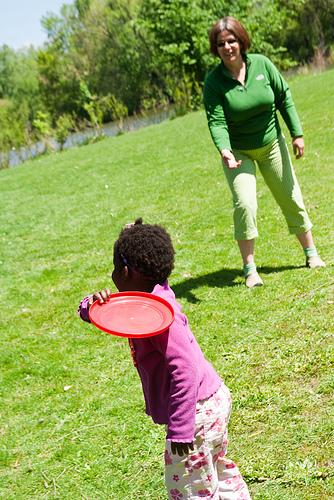Count and describe the patches of green grass depicted in the image. There are 17 patches of green grass, varying in size and position throughout the image. Describe the scene where the people are playing frisbee. The scene takes place in a green grassy field with patches of grass scattered around. The small child is holding the frisbee, preparing to throw it while the woman is nearby, possibly observing or participating in the activity. Describe the sentiment or emotions conveyed in the image. The image portrays a positive and playful atmosphere with the small child and woman enjoying outdoor activities on a sunny day. What kind of clothing accessory does the small child have on her head? The small child is wearing a purple headband in her hair. Explain the quality of the image based on the provided information. The image seems to have a decent quality, with details of clothing, location, and various objects clearly described, allowing for accurate object detection and analysis tasks. What objects are being held by the people in the image? The small child is holding a frisbee, while the woman does not appear to be holding any objects. Analyze the interaction between the small child and the woman in the image. The small child is preparing to throw the frisbee, while the woman is present, possibly watching or supervising the child's playtime. Determine the number of objects within the image in the image. There are 40 objects identified within the image, including people, clothing items, grass patches, and other specific details. Identify the colors of the clothing worn by the small child and the woman. The small child is wearing a purple headband, purple shirt, and white pants with purple flowers. The woman is wearing a dark green shirt and light green capris. Based on the image, what is the main activity taking place between the people? They are playing frisbee in the grass. What is the color and location of the branches and leaves described in the image? On the grass What color is the frisbee that the small child is holding? Red Describe the presence of any garden elements in the image. There are small patches of green grass and branches and leaves on the grass. In the image, what accessory is the little girl wearing in her hair? A purple headband Is it possible to detect the emotion of the little girl from the image? Cannot determine, as her facial expression is not visible. What is the emotion exhibited by the woman in the image? Cannot determine, her facial expression is not visible What activity are the people in the image participating in? Playing frisbee Express the image caption using poetic language. Amidst verdant fields of play, a tiny cherub grasps a crimson disk, preparing to take flight. What color are the socks the woman is wearing? Green Is the child about to engage in an activity involving the red frisbee? If so, provide details. Yes, the child is getting ready to throw the frisbee. Is the lady dressed in capris, and if so, what color are they? Yes, the capris are light green. Which subject is wearing a dark green shirt? The woman Describe the pattern on the white pants in the image. Purple flowers Create a haiku poem based on the image content. Child on grassy field, Explain the event taking place between the woman and the child in the photo. The child is getting ready to throw a frisbee with the woman. Analyze the diagram to identify which part of the woman's outfit contains pink flowers. Her pants Which of these descriptions best fits the child's shirt? a) Red b) Purple c) Blue d) Yellow b) Purple Identify the presence of any unusual patterns or designs on the white pants. There are pink flowers on the pants. 